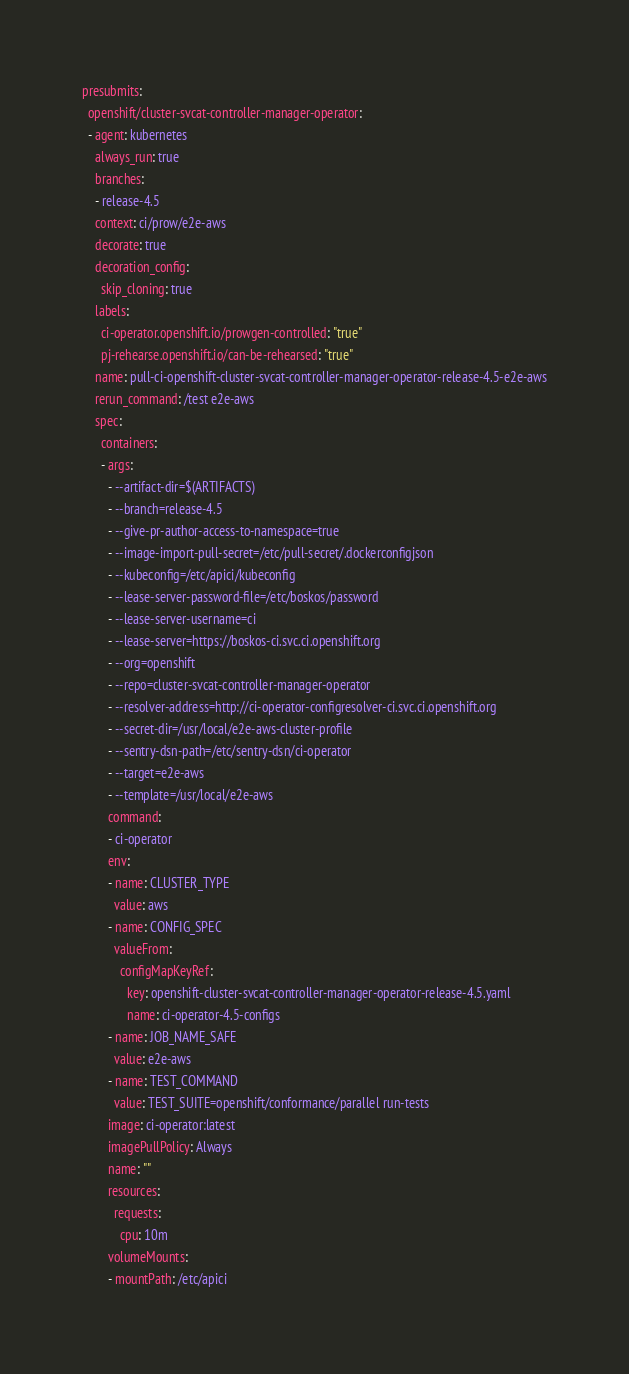Convert code to text. <code><loc_0><loc_0><loc_500><loc_500><_YAML_>presubmits:
  openshift/cluster-svcat-controller-manager-operator:
  - agent: kubernetes
    always_run: true
    branches:
    - release-4.5
    context: ci/prow/e2e-aws
    decorate: true
    decoration_config:
      skip_cloning: true
    labels:
      ci-operator.openshift.io/prowgen-controlled: "true"
      pj-rehearse.openshift.io/can-be-rehearsed: "true"
    name: pull-ci-openshift-cluster-svcat-controller-manager-operator-release-4.5-e2e-aws
    rerun_command: /test e2e-aws
    spec:
      containers:
      - args:
        - --artifact-dir=$(ARTIFACTS)
        - --branch=release-4.5
        - --give-pr-author-access-to-namespace=true
        - --image-import-pull-secret=/etc/pull-secret/.dockerconfigjson
        - --kubeconfig=/etc/apici/kubeconfig
        - --lease-server-password-file=/etc/boskos/password
        - --lease-server-username=ci
        - --lease-server=https://boskos-ci.svc.ci.openshift.org
        - --org=openshift
        - --repo=cluster-svcat-controller-manager-operator
        - --resolver-address=http://ci-operator-configresolver-ci.svc.ci.openshift.org
        - --secret-dir=/usr/local/e2e-aws-cluster-profile
        - --sentry-dsn-path=/etc/sentry-dsn/ci-operator
        - --target=e2e-aws
        - --template=/usr/local/e2e-aws
        command:
        - ci-operator
        env:
        - name: CLUSTER_TYPE
          value: aws
        - name: CONFIG_SPEC
          valueFrom:
            configMapKeyRef:
              key: openshift-cluster-svcat-controller-manager-operator-release-4.5.yaml
              name: ci-operator-4.5-configs
        - name: JOB_NAME_SAFE
          value: e2e-aws
        - name: TEST_COMMAND
          value: TEST_SUITE=openshift/conformance/parallel run-tests
        image: ci-operator:latest
        imagePullPolicy: Always
        name: ""
        resources:
          requests:
            cpu: 10m
        volumeMounts:
        - mountPath: /etc/apici</code> 